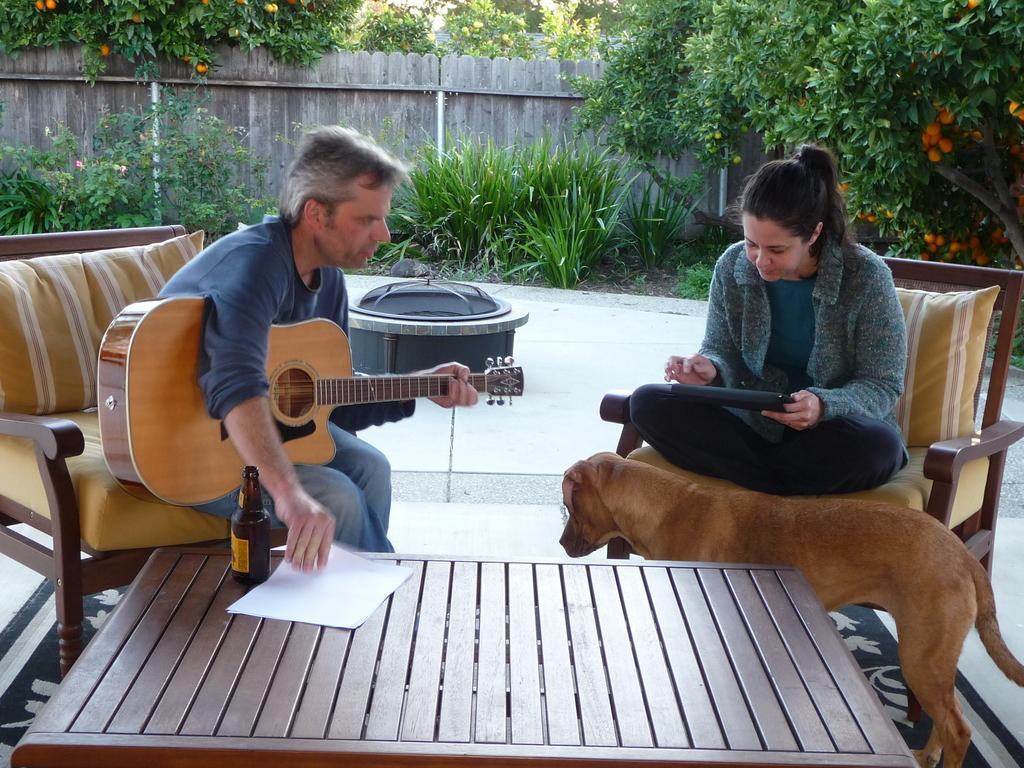Describe this image in one or two sentences. In this image i can see a man sitting in the couch and holding a guitar and a paper in his hands. To the right of the image i can see a woman sitting on the couch and a dog. In the background i can see trees, a fence wall and the floor. 